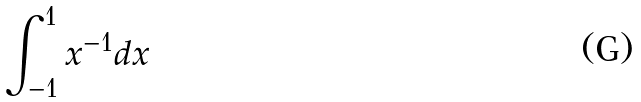Convert formula to latex. <formula><loc_0><loc_0><loc_500><loc_500>\int _ { - 1 } ^ { 1 } x ^ { - 1 } d x</formula> 